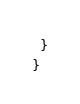Convert code to text. <code><loc_0><loc_0><loc_500><loc_500><_TypeScript_>  }
}
</code> 